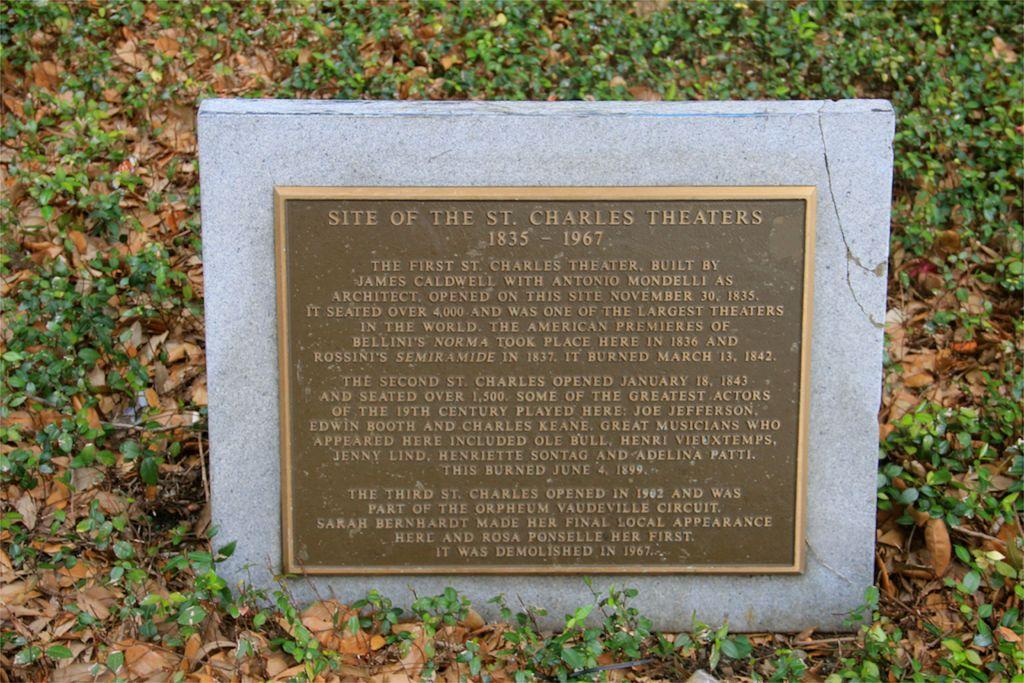Please provide a concise description of this image. In this image we can see a memorial with text placed on the ground. In the background, we can see group of plants. 